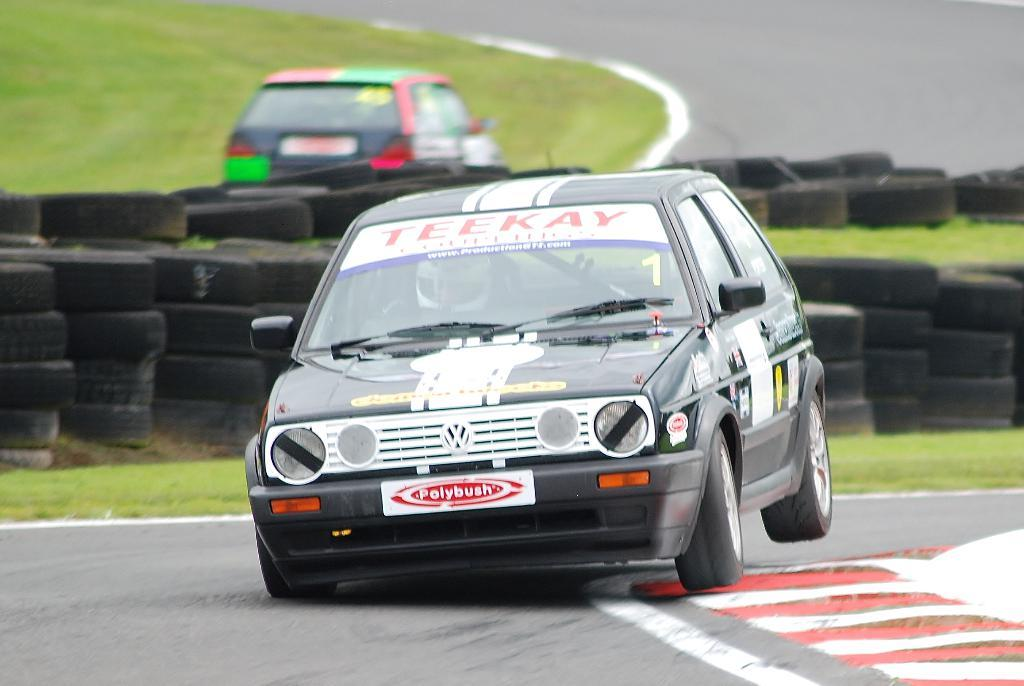What objects are present in the image? There are tires and cars in the image. Can you describe the location of the cars in the image? The cars are in the middle of the image. What type of receipt can be seen in the image? There is no receipt present in the image. 